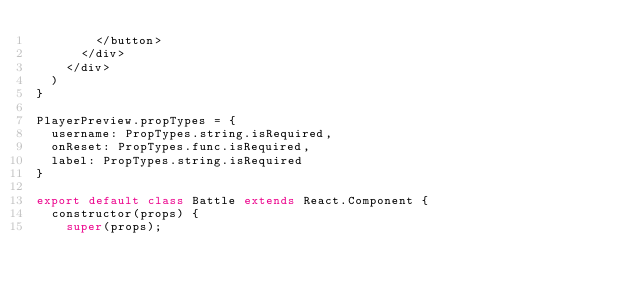<code> <loc_0><loc_0><loc_500><loc_500><_JavaScript_>        </button>
      </div>
    </div>
  )
}

PlayerPreview.propTypes = {
  username: PropTypes.string.isRequired,
  onReset: PropTypes.func.isRequired,
  label: PropTypes.string.isRequired
}

export default class Battle extends React.Component {
  constructor(props) {
    super(props);
</code> 